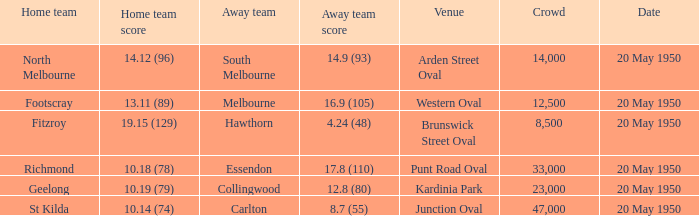What was the date of the match when the visiting team was south melbourne? 20 May 1950. 